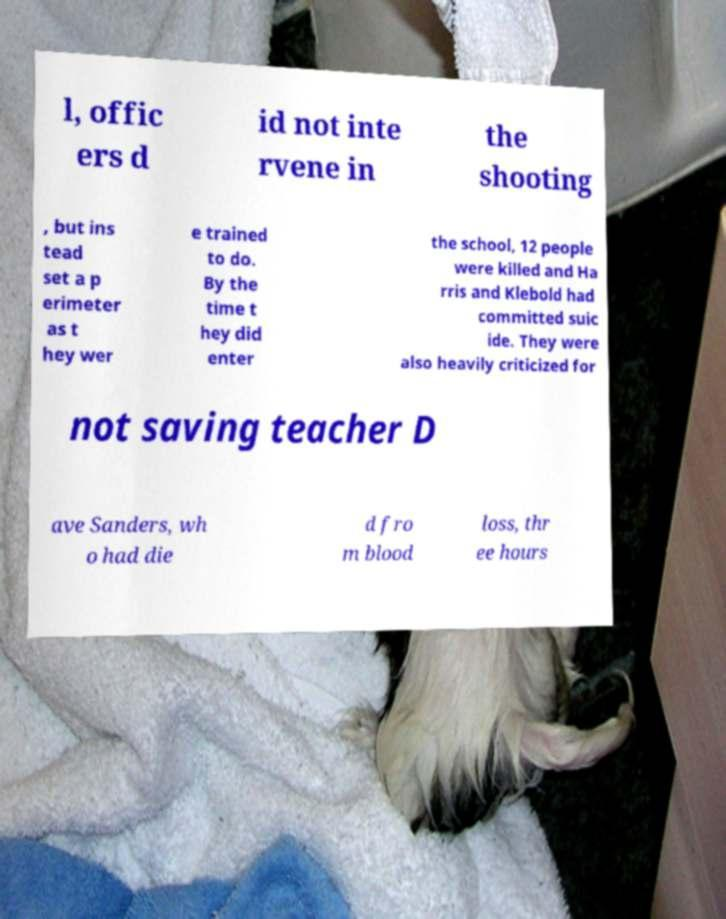Please read and relay the text visible in this image. What does it say? l, offic ers d id not inte rvene in the shooting , but ins tead set a p erimeter as t hey wer e trained to do. By the time t hey did enter the school, 12 people were killed and Ha rris and Klebold had committed suic ide. They were also heavily criticized for not saving teacher D ave Sanders, wh o had die d fro m blood loss, thr ee hours 